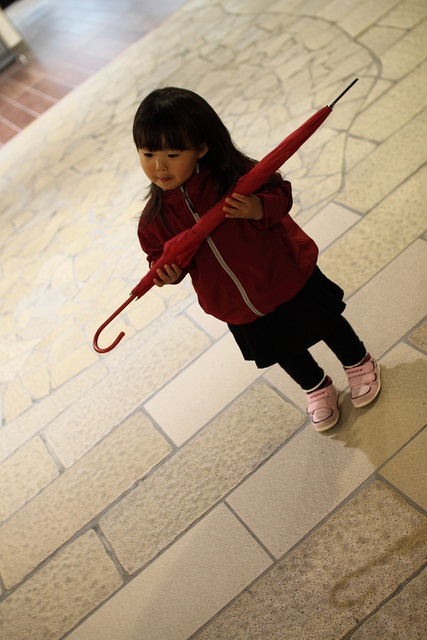Describe the objects in this image and their specific colors. I can see people in black, maroon, and gray tones and umbrella in black, maroon, and brown tones in this image. 